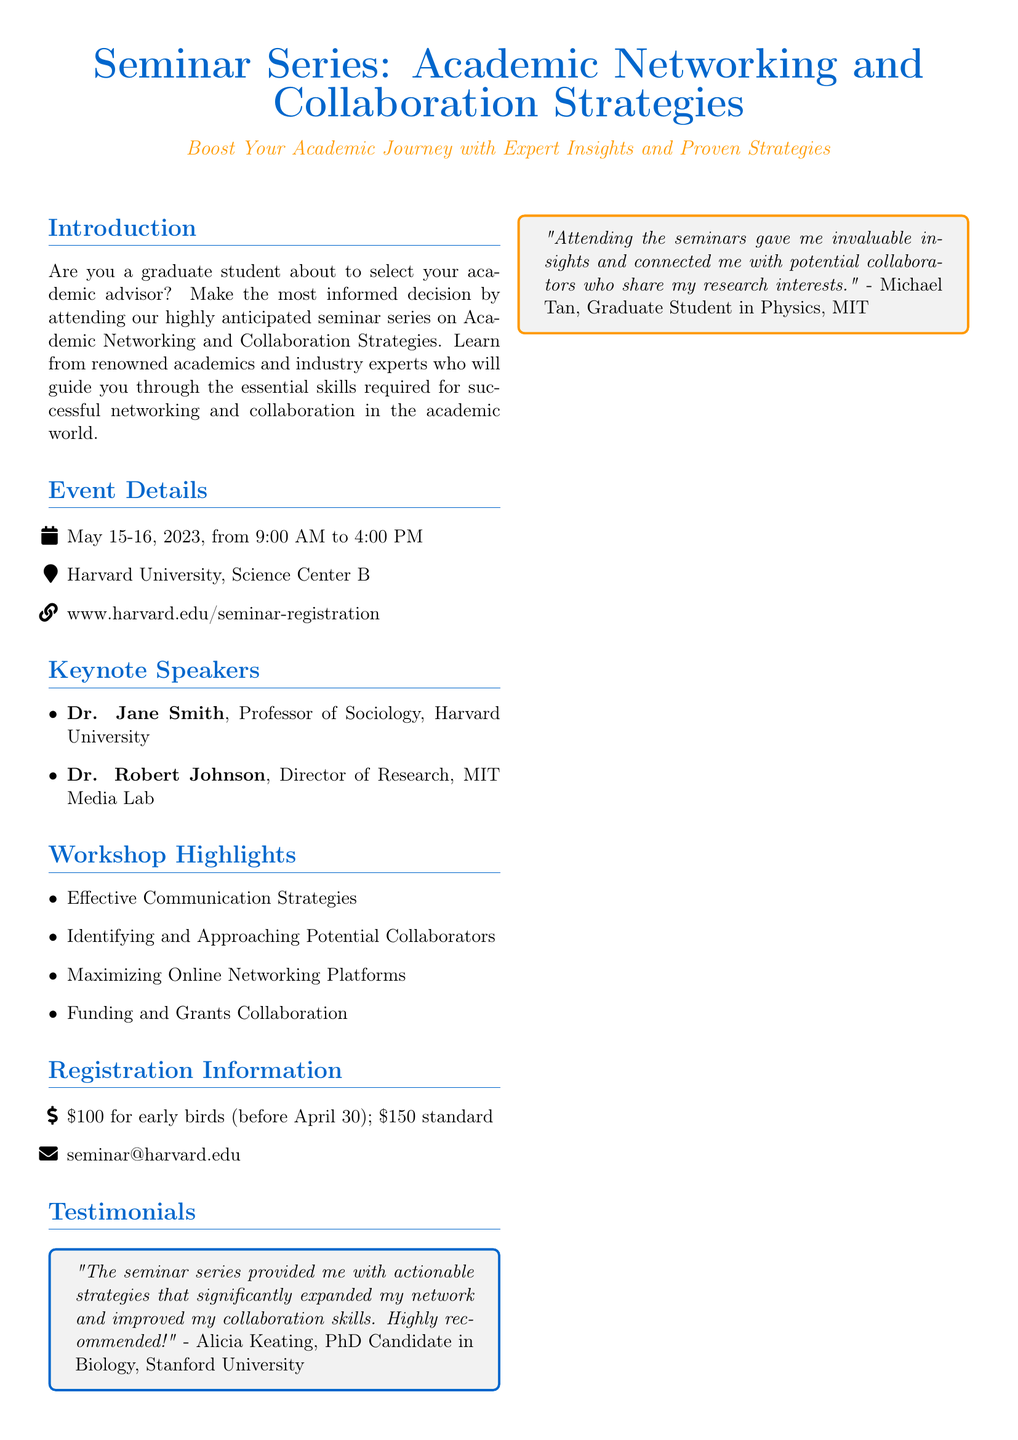What are the dates of the seminar? The dates of the seminar are specified in the Event Details section of the document.
Answer: May 15-16, 2023 Where is the seminar located? The location of the seminar is mentioned in the Event Details section of the document.
Answer: Harvard University, Science Center B Who is one of the keynote speakers? The keynote speakers are listed in the Keynote Speakers section of the document.
Answer: Dr. Jane Smith What is the early bird registration fee? The early bird registration fee is mentioned in the Registration Information section.
Answer: $100 What are some workshop highlights? The workshop highlights are listed in the Workshop Highlights section of the document.
Answer: Effective Communication Strategies How can I register for the seminar? The method to register for the seminar is provided in the Registration Information section of the document.
Answer: www.harvard.edu/seminar-registration What is the testimonial from Alicia Keating? The testimonial from Alicia Keating is provided in the Testimonials section of the document.
Answer: "The seminar series provided me with actionable strategies that significantly expanded my network and improved my collaboration skills. Highly recommended!" Which organization is listed as a sponsor? The sponsors are listed in the Sponsors section of the document.
Answer: National Science Foundation How does attending the seminar benefit graduate students? This benefit is inferred from the Introduction section and testimonials discussing networking and collaboration.
Answer: Expands network and improves collaboration skills 